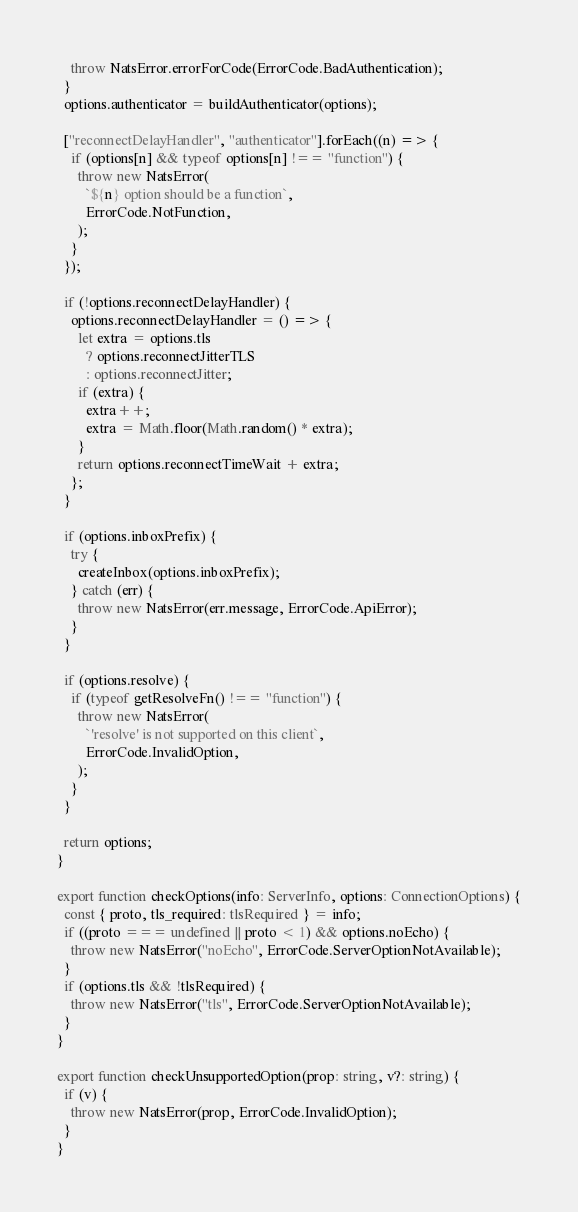<code> <loc_0><loc_0><loc_500><loc_500><_TypeScript_>    throw NatsError.errorForCode(ErrorCode.BadAuthentication);
  }
  options.authenticator = buildAuthenticator(options);

  ["reconnectDelayHandler", "authenticator"].forEach((n) => {
    if (options[n] && typeof options[n] !== "function") {
      throw new NatsError(
        `${n} option should be a function`,
        ErrorCode.NotFunction,
      );
    }
  });

  if (!options.reconnectDelayHandler) {
    options.reconnectDelayHandler = () => {
      let extra = options.tls
        ? options.reconnectJitterTLS
        : options.reconnectJitter;
      if (extra) {
        extra++;
        extra = Math.floor(Math.random() * extra);
      }
      return options.reconnectTimeWait + extra;
    };
  }

  if (options.inboxPrefix) {
    try {
      createInbox(options.inboxPrefix);
    } catch (err) {
      throw new NatsError(err.message, ErrorCode.ApiError);
    }
  }

  if (options.resolve) {
    if (typeof getResolveFn() !== "function") {
      throw new NatsError(
        `'resolve' is not supported on this client`,
        ErrorCode.InvalidOption,
      );
    }
  }

  return options;
}

export function checkOptions(info: ServerInfo, options: ConnectionOptions) {
  const { proto, tls_required: tlsRequired } = info;
  if ((proto === undefined || proto < 1) && options.noEcho) {
    throw new NatsError("noEcho", ErrorCode.ServerOptionNotAvailable);
  }
  if (options.tls && !tlsRequired) {
    throw new NatsError("tls", ErrorCode.ServerOptionNotAvailable);
  }
}

export function checkUnsupportedOption(prop: string, v?: string) {
  if (v) {
    throw new NatsError(prop, ErrorCode.InvalidOption);
  }
}
</code> 